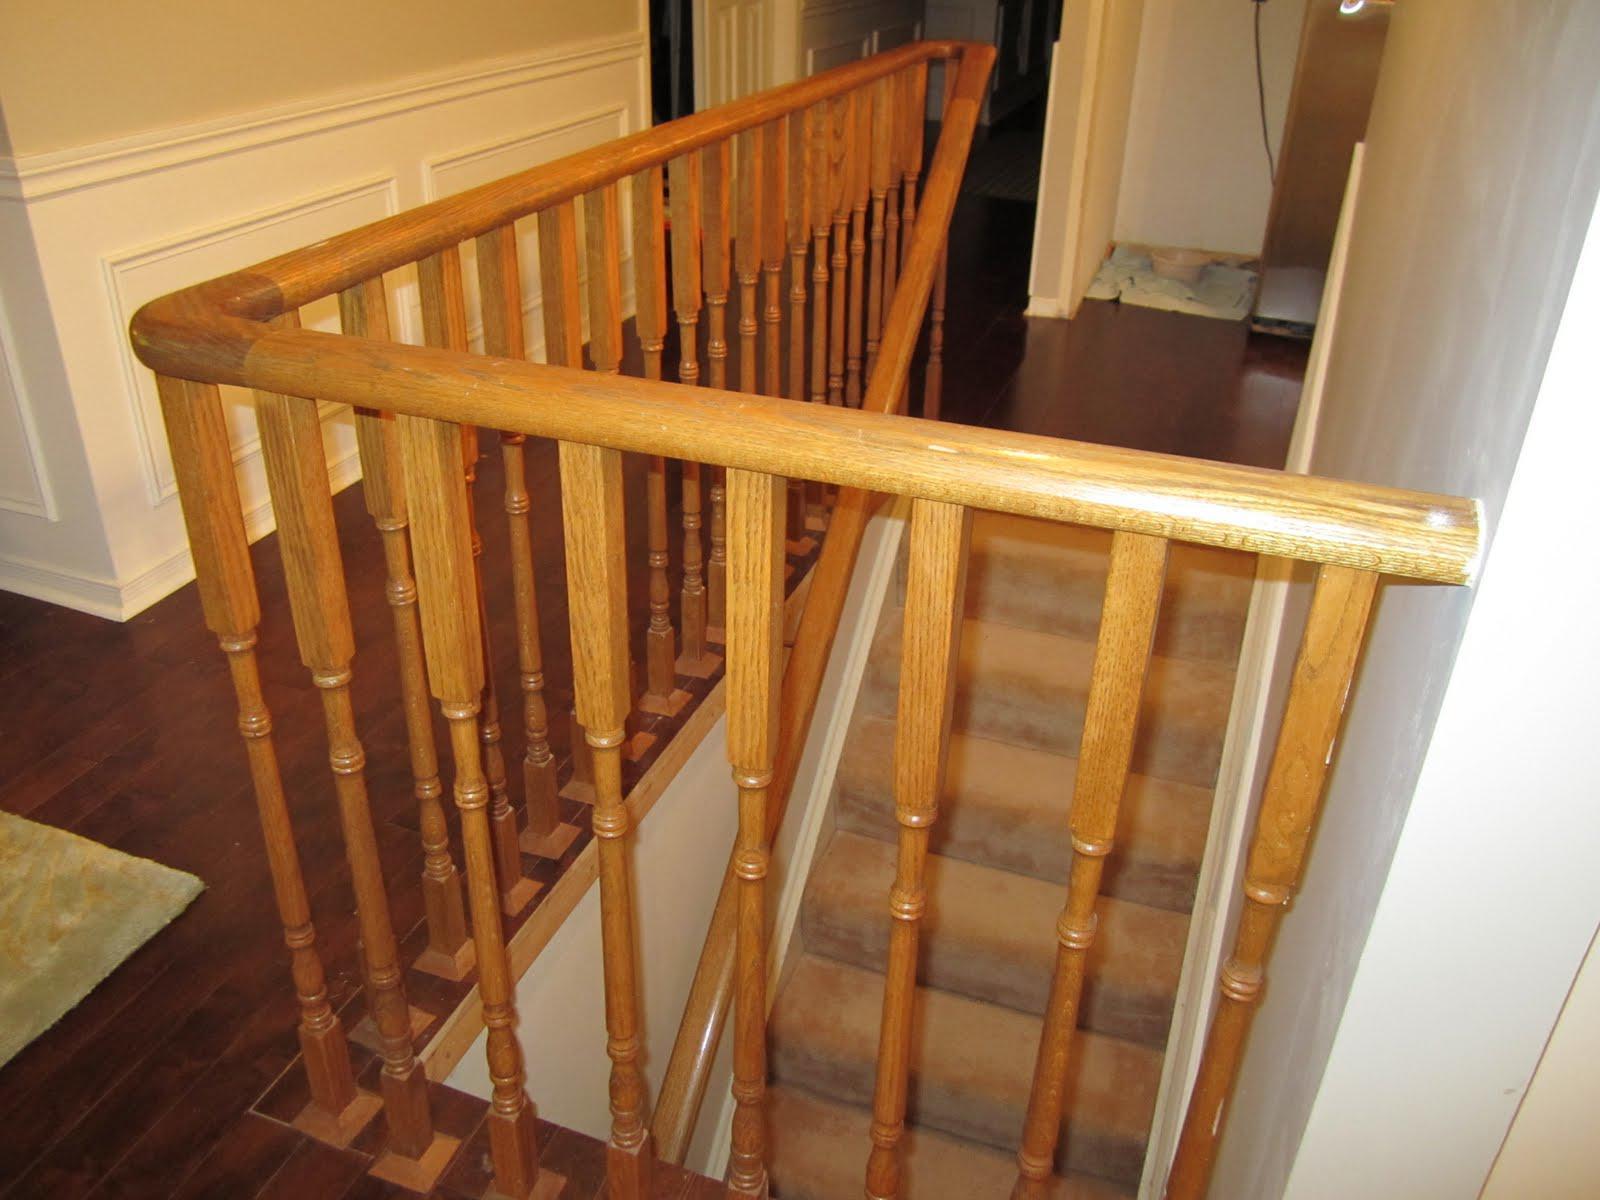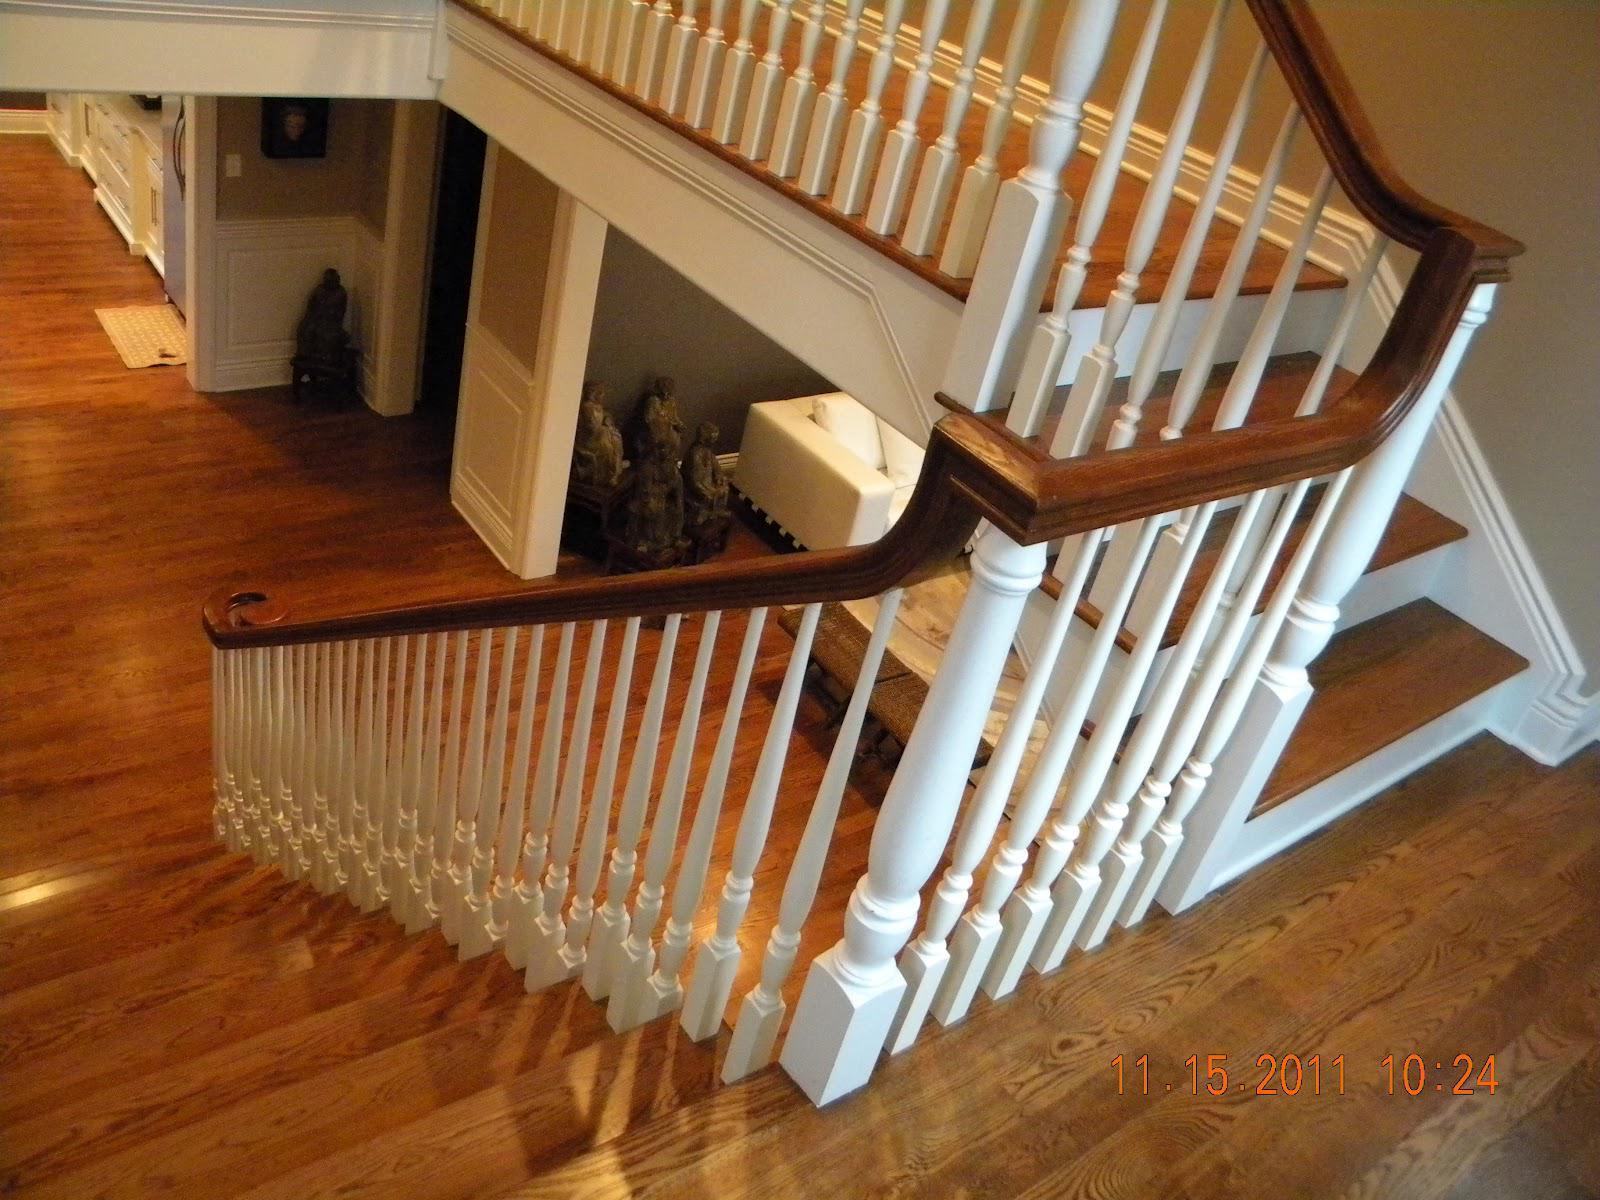The first image is the image on the left, the second image is the image on the right. Analyze the images presented: Is the assertion "One image features a staircase that takes a turn to the right and has dark rails with vertical wrought iron bars accented with circle shapes." valid? Answer yes or no. No. The first image is the image on the left, the second image is the image on the right. Given the left and right images, does the statement "One of the railings is white." hold true? Answer yes or no. Yes. 